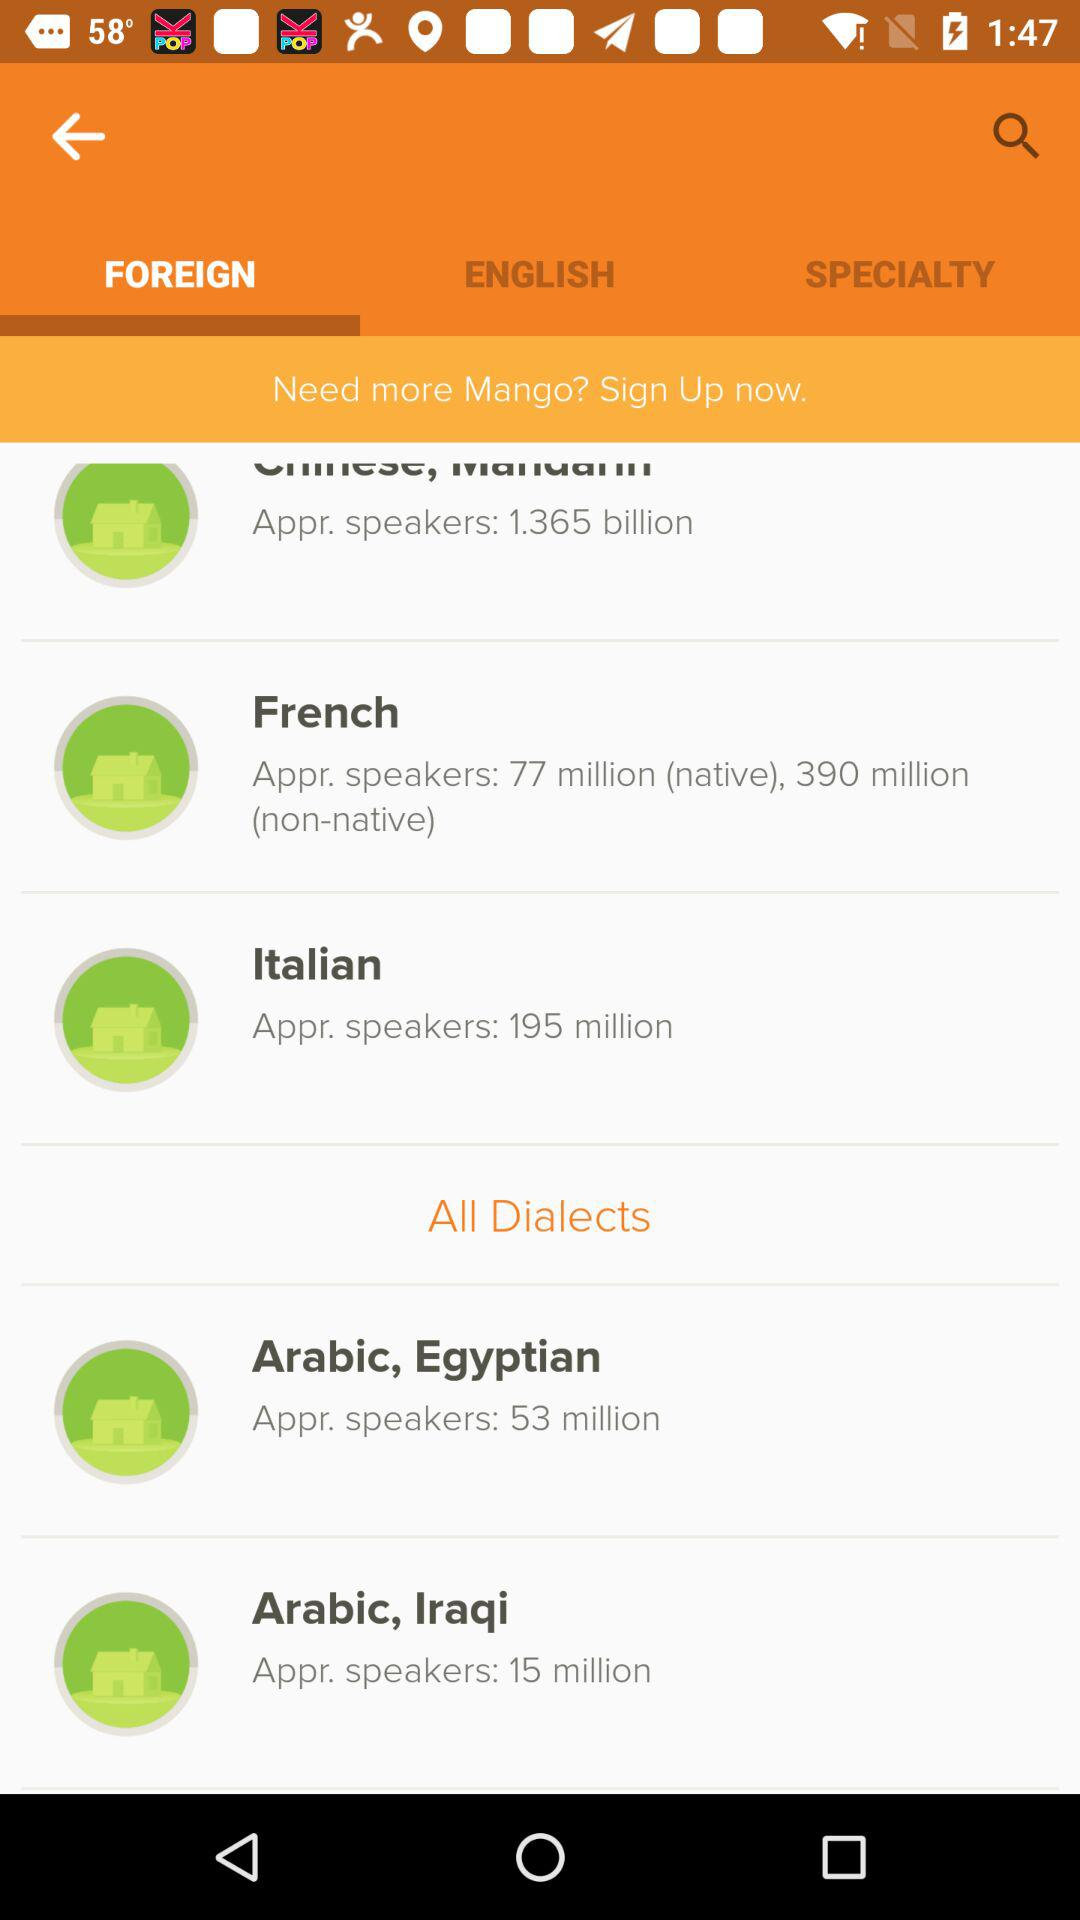How many approximate speakers are there in Arabic, Iraqi? There are approximately 15 million speakers. 